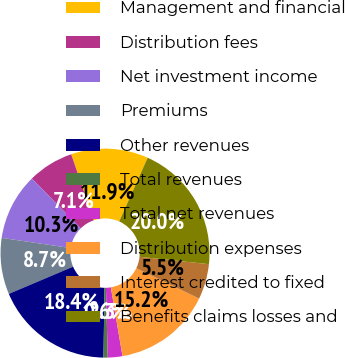Convert chart. <chart><loc_0><loc_0><loc_500><loc_500><pie_chart><fcel>Management and financial<fcel>Distribution fees<fcel>Net investment income<fcel>Premiums<fcel>Other revenues<fcel>Total revenues<fcel>Total net revenues<fcel>Distribution expenses<fcel>Interest credited to fixed<fcel>Benefits claims losses and<nl><fcel>11.94%<fcel>7.1%<fcel>10.32%<fcel>8.71%<fcel>18.39%<fcel>0.65%<fcel>2.26%<fcel>15.16%<fcel>5.48%<fcel>20.0%<nl></chart> 